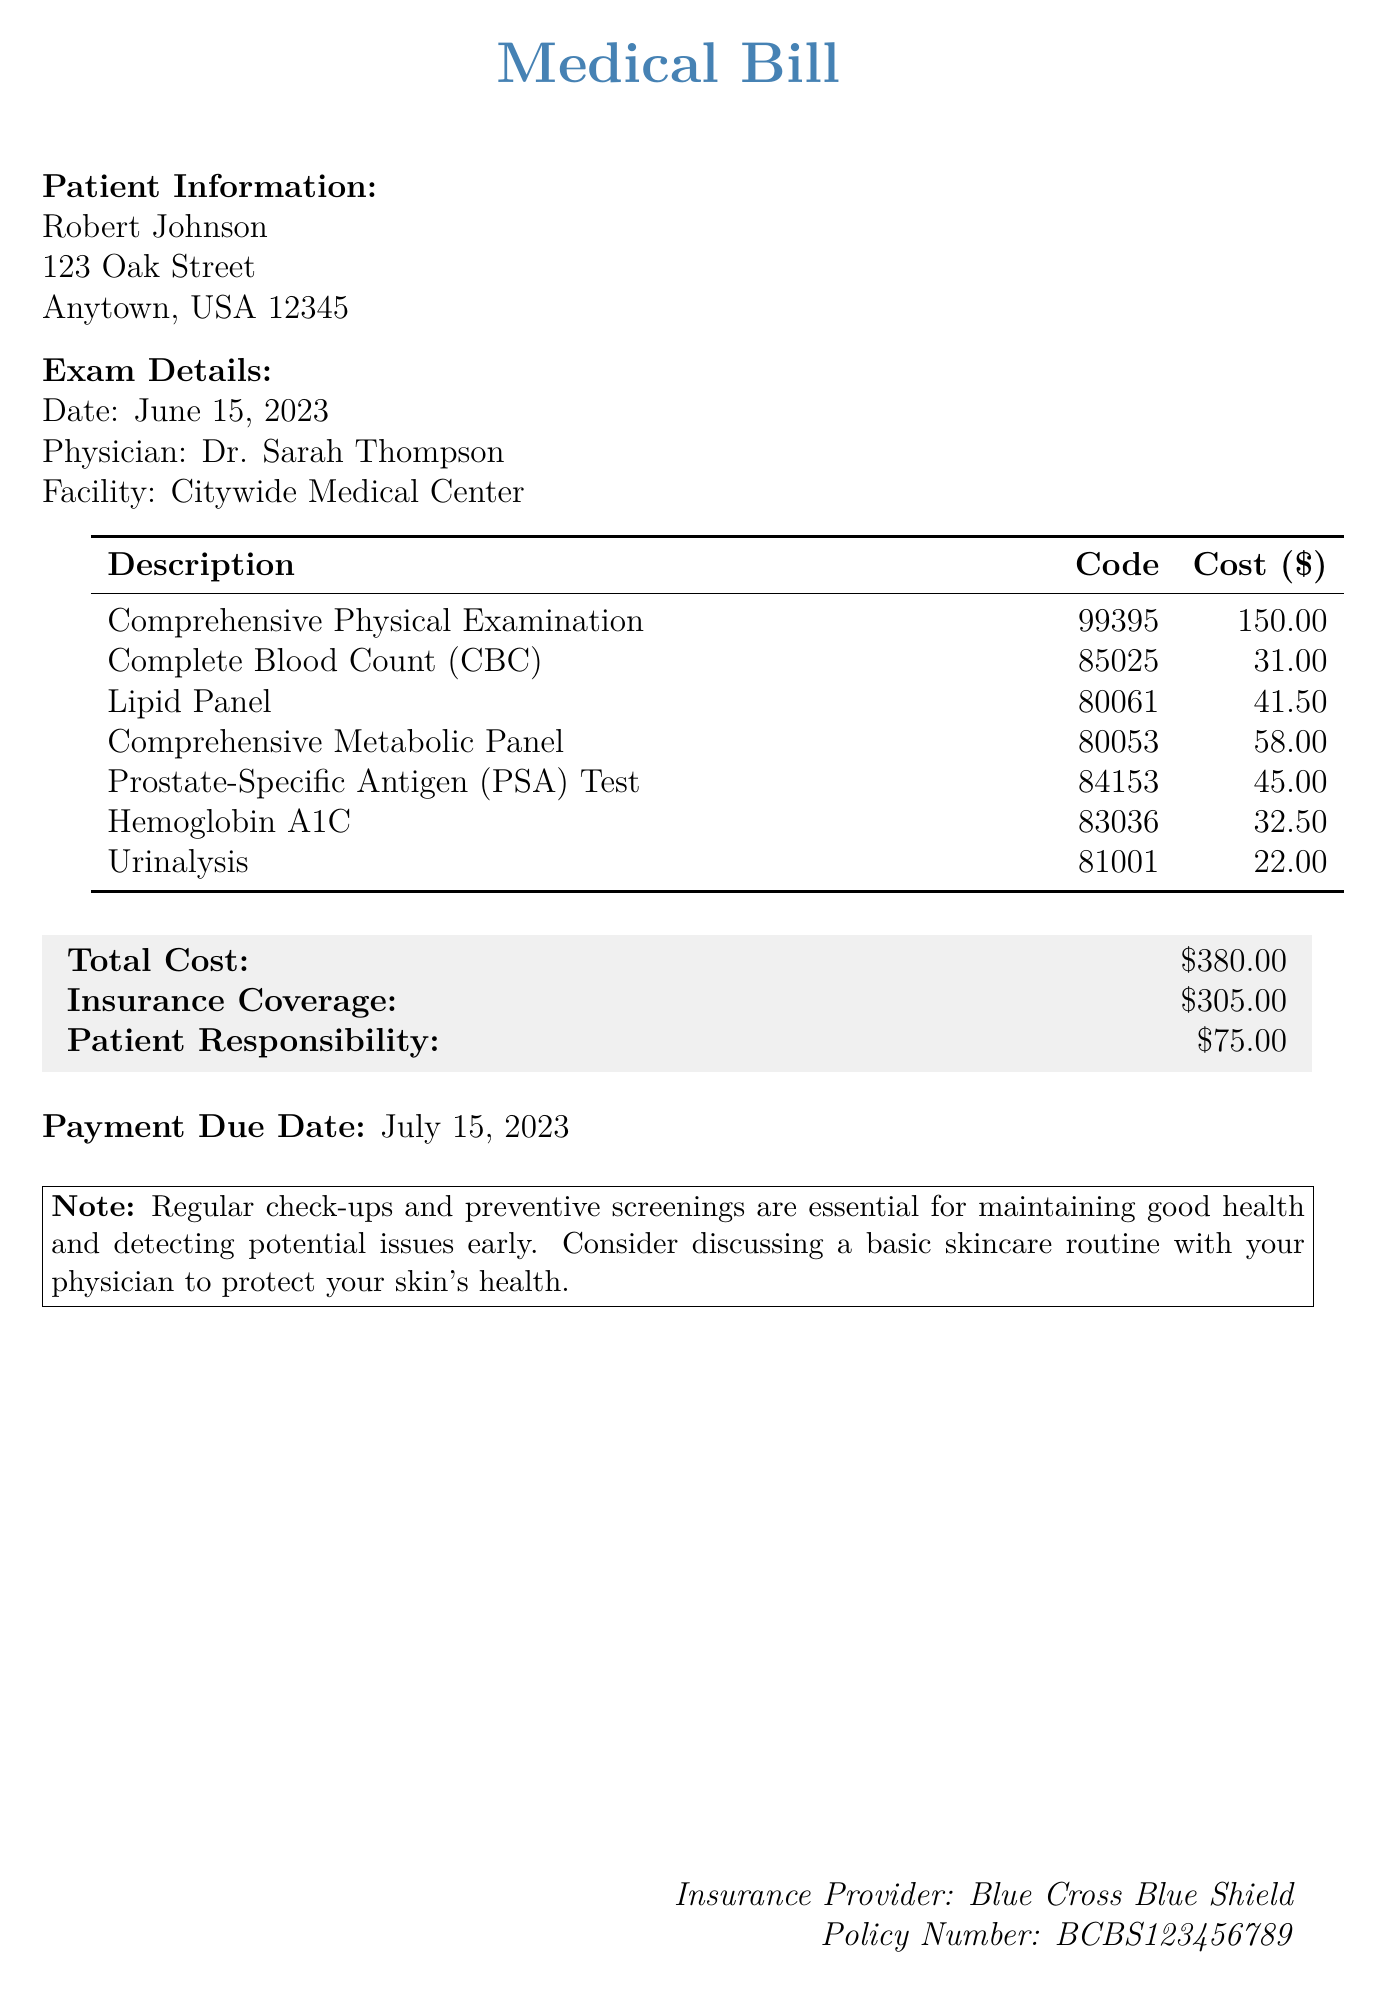what is the date of the examination? The date of the examination is mentioned in the exam details section of the document.
Answer: June 15, 2023 who was the physician for the examination? The physician's name is listed in the exam details section.
Answer: Dr. Sarah Thompson what is the total cost of the bill? The total cost is displayed at the bottom of the bill in the cost summary section.
Answer: $380.00 how much did the insurance cover? The insurance coverage amount is provided in the cost summary section of the bill.
Answer: $305.00 what is the patient’s responsibility after insurance coverage? The patient responsibility amount is indicated in the cost summary section.
Answer: $75.00 how many laboratory tests were performed? The number of tests can be counted from the description section and the table of services.
Answer: 7 what is the purpose of the note at the bottom of the bill? The note emphasizes the importance of regular check-ups and preventive screenings.
Answer: Maintaining good health when is the payment due date? The payment due date is specified at the end of the document.
Answer: July 15, 2023 what type of insurance is mentioned? The type of insurance is stated at the bottom of the document.
Answer: Blue Cross Blue Shield 